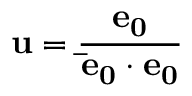Convert formula to latex. <formula><loc_0><loc_0><loc_500><loc_500>u = \frac { e _ { 0 } } { \bar { e } _ { 0 } \cdot e _ { 0 } }</formula> 